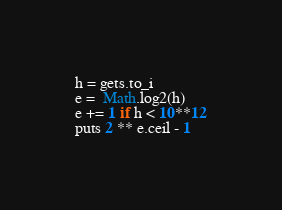Convert code to text. <code><loc_0><loc_0><loc_500><loc_500><_Ruby_>h = gets.to_i
e =  Math.log2(h)
e += 1 if h < 10**12
puts 2 ** e.ceil - 1

</code> 